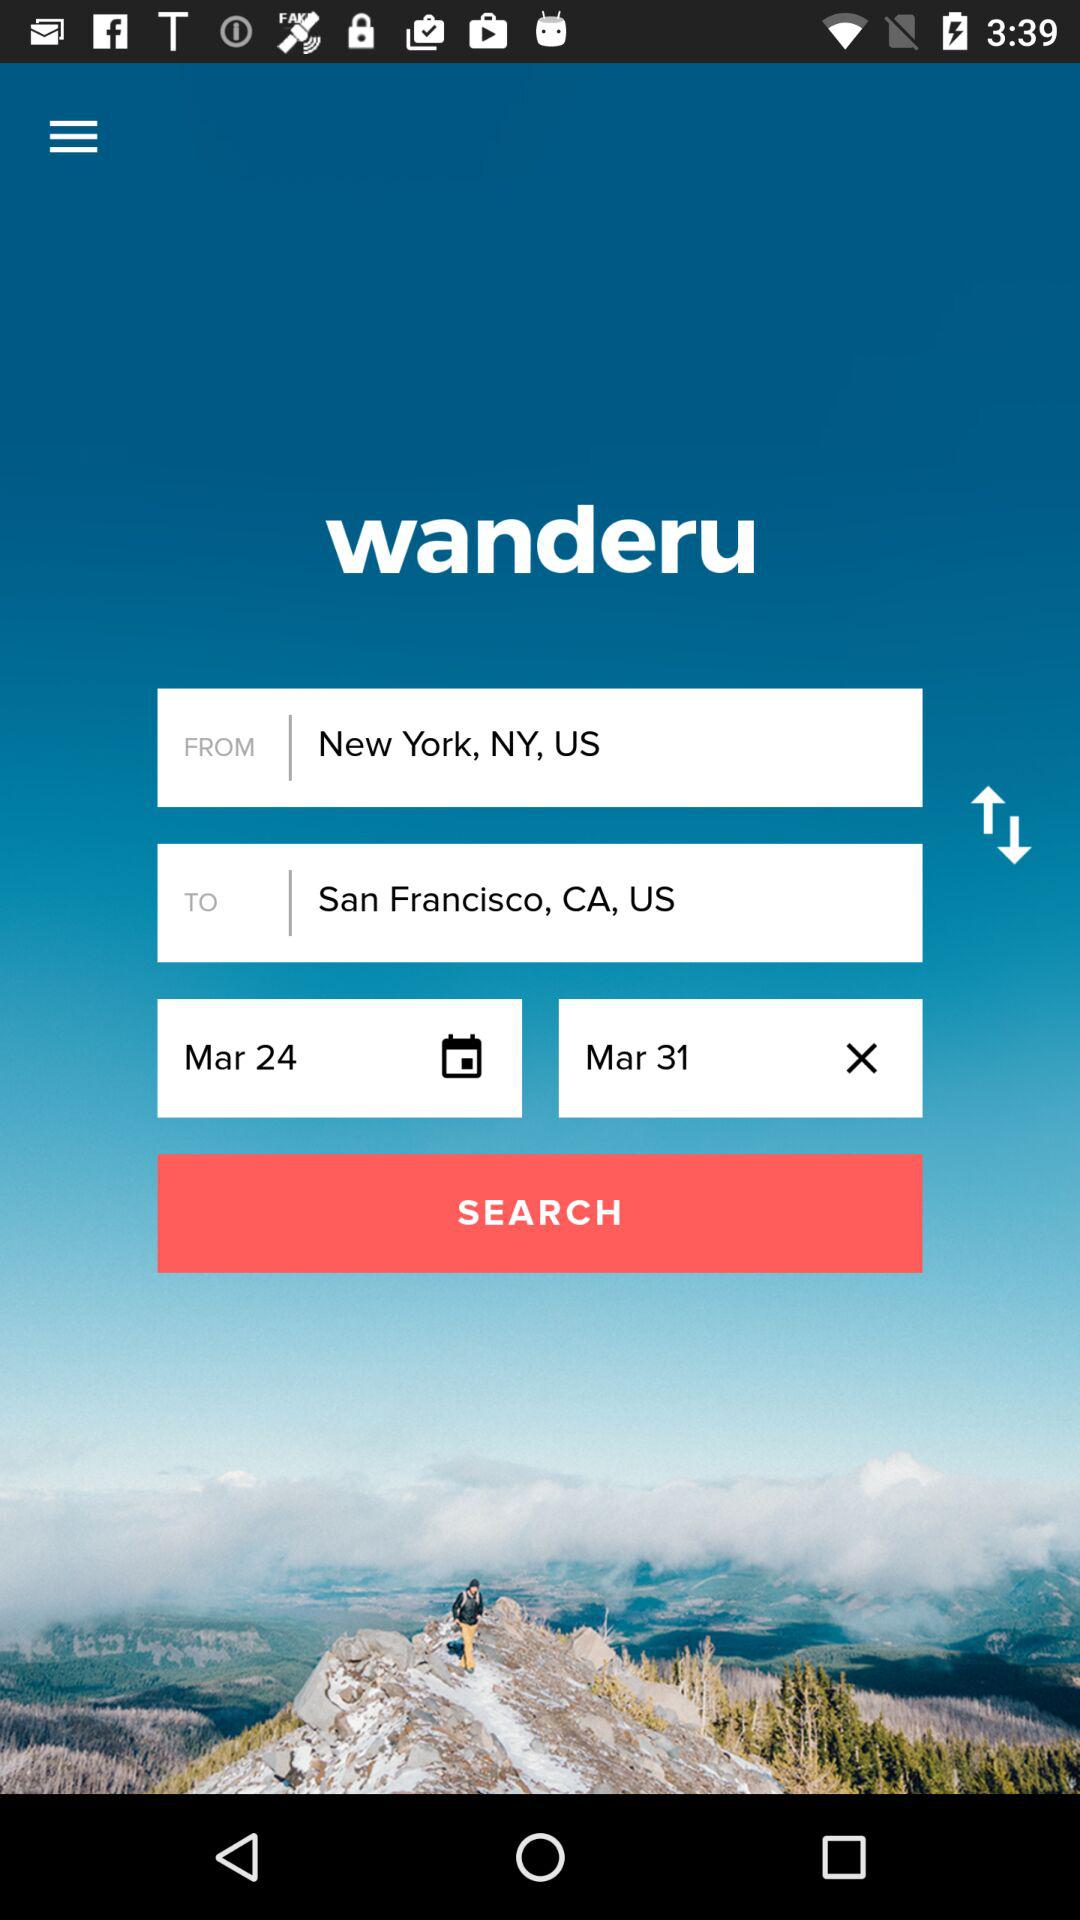For which date is the travel scheduled? The travel is scheduled for March 24 and March 31. 